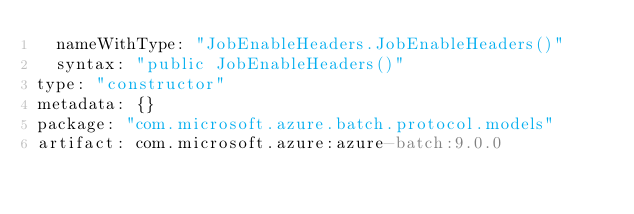<code> <loc_0><loc_0><loc_500><loc_500><_YAML_>  nameWithType: "JobEnableHeaders.JobEnableHeaders()"
  syntax: "public JobEnableHeaders()"
type: "constructor"
metadata: {}
package: "com.microsoft.azure.batch.protocol.models"
artifact: com.microsoft.azure:azure-batch:9.0.0
</code> 